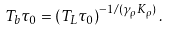Convert formula to latex. <formula><loc_0><loc_0><loc_500><loc_500>T _ { b } \tau _ { 0 } = \left ( T _ { L } \tau _ { 0 } \right ) ^ { - 1 / ( \gamma _ { \rho } K _ { \rho } ) } .</formula> 